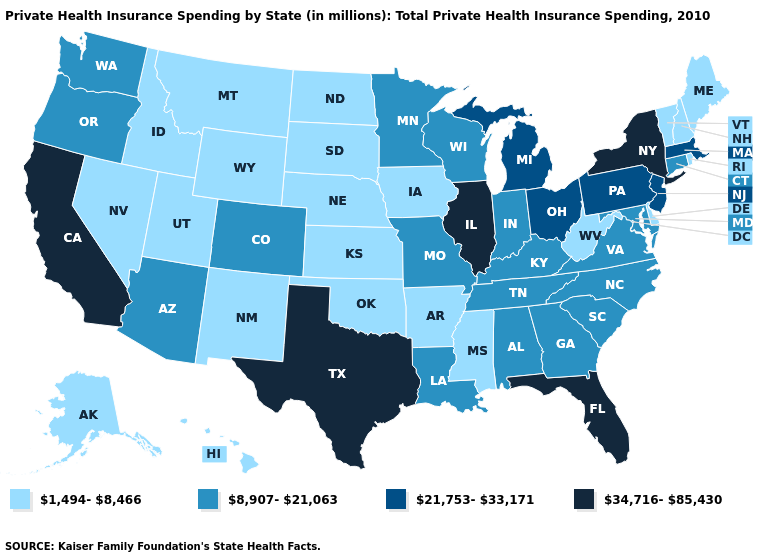Name the states that have a value in the range 1,494-8,466?
Write a very short answer. Alaska, Arkansas, Delaware, Hawaii, Idaho, Iowa, Kansas, Maine, Mississippi, Montana, Nebraska, Nevada, New Hampshire, New Mexico, North Dakota, Oklahoma, Rhode Island, South Dakota, Utah, Vermont, West Virginia, Wyoming. Which states hav the highest value in the West?
Answer briefly. California. What is the value of Washington?
Short answer required. 8,907-21,063. What is the lowest value in the USA?
Give a very brief answer. 1,494-8,466. Does Georgia have the same value as Tennessee?
Answer briefly. Yes. Name the states that have a value in the range 34,716-85,430?
Short answer required. California, Florida, Illinois, New York, Texas. Among the states that border Nebraska , does Missouri have the highest value?
Concise answer only. Yes. Does California have the highest value in the West?
Answer briefly. Yes. Name the states that have a value in the range 8,907-21,063?
Write a very short answer. Alabama, Arizona, Colorado, Connecticut, Georgia, Indiana, Kentucky, Louisiana, Maryland, Minnesota, Missouri, North Carolina, Oregon, South Carolina, Tennessee, Virginia, Washington, Wisconsin. Does Virginia have the highest value in the South?
Short answer required. No. What is the value of New Mexico?
Be succinct. 1,494-8,466. What is the value of Massachusetts?
Quick response, please. 21,753-33,171. What is the lowest value in the South?
Answer briefly. 1,494-8,466. What is the lowest value in states that border Colorado?
Be succinct. 1,494-8,466. Name the states that have a value in the range 34,716-85,430?
Concise answer only. California, Florida, Illinois, New York, Texas. 